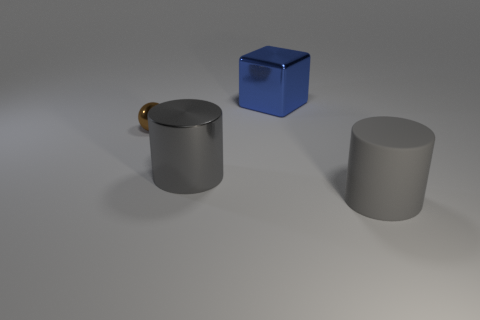Add 1 gray shiny things. How many objects exist? 5 Subtract all balls. How many objects are left? 3 Add 1 blue metal blocks. How many blue metal blocks exist? 2 Subtract 0 brown cubes. How many objects are left? 4 Subtract all large yellow cylinders. Subtract all gray cylinders. How many objects are left? 2 Add 3 gray things. How many gray things are left? 5 